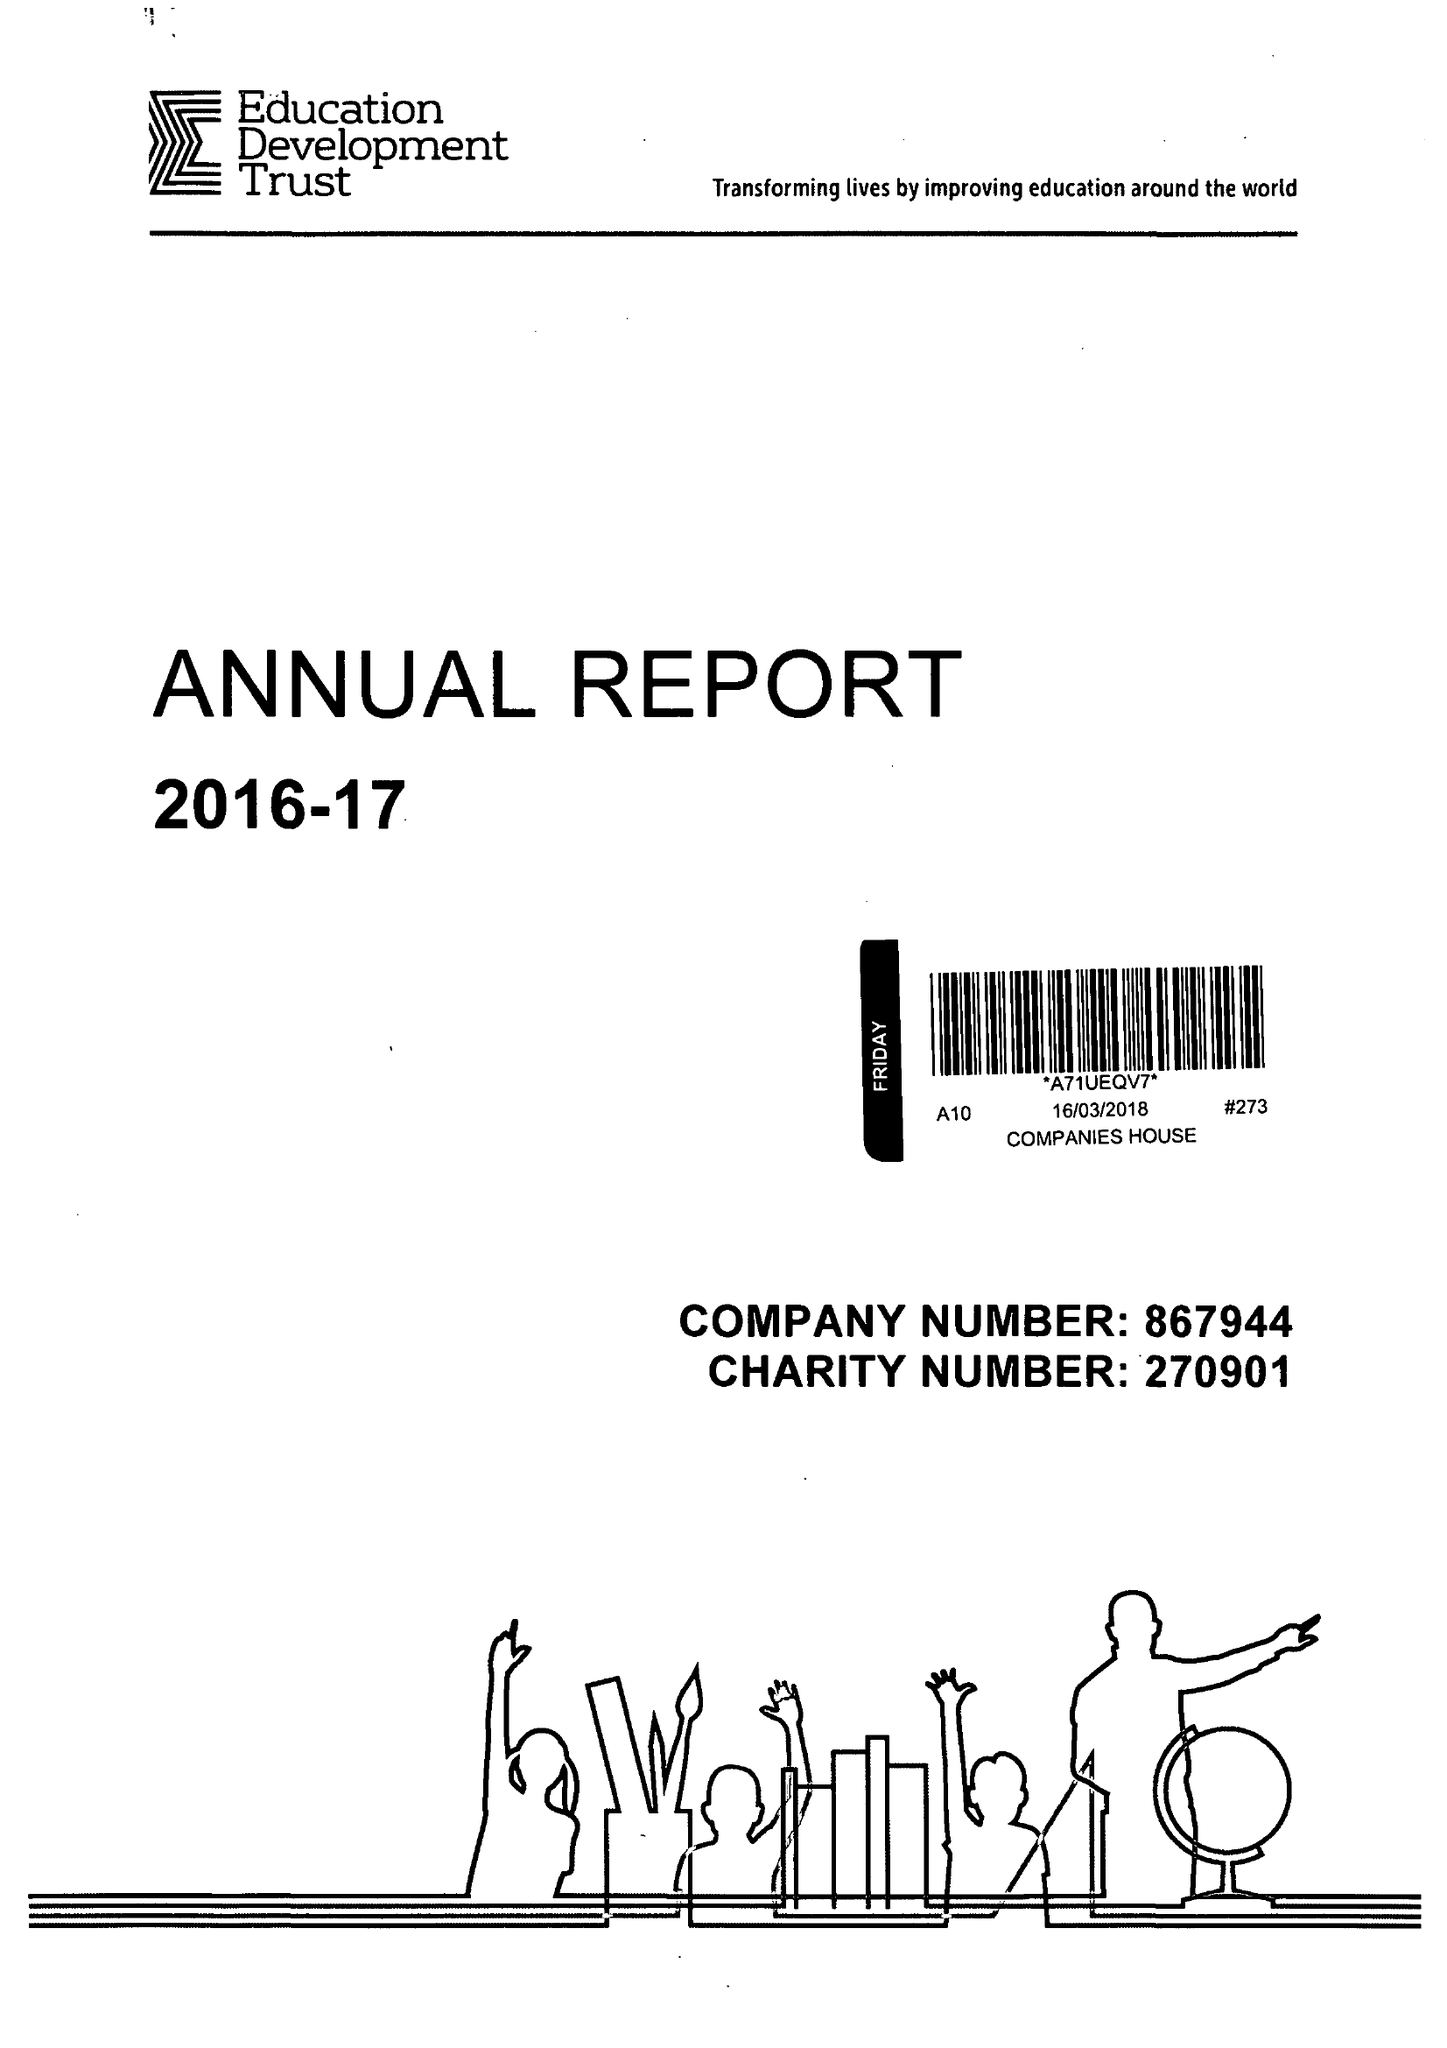What is the value for the income_annually_in_british_pounds?
Answer the question using a single word or phrase. 68020000.00 